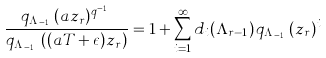Convert formula to latex. <formula><loc_0><loc_0><loc_500><loc_500>\frac { q _ { \Lambda _ { r - 1 } } ( a z _ { r } ) ^ { q ^ { r - 1 } } } { q _ { \Lambda _ { r - 1 } } \left ( ( a T + \epsilon ) z _ { r } \right ) } = 1 + \sum _ { i = 1 } ^ { \infty } d _ { i } ( \Lambda _ { r - 1 } ) \, q _ { \Lambda _ { r - 1 } } ( z _ { r } ) ^ { i }</formula> 